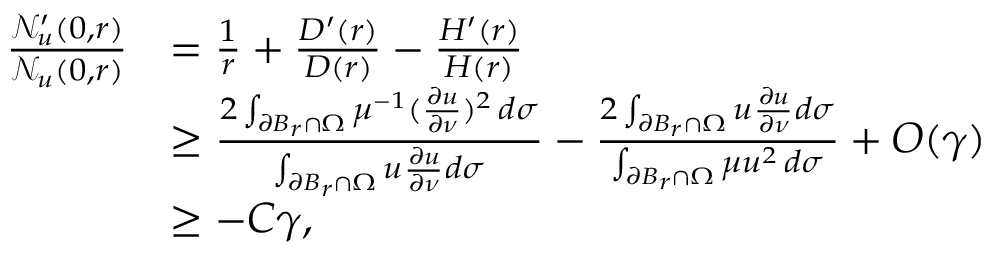<formula> <loc_0><loc_0><loc_500><loc_500>\begin{array} { r } { \begin{array} { r l } { \frac { \mathcal { N } _ { u } ^ { \prime } ( 0 , r ) } { \mathcal { N } _ { u } ( 0 , r ) } } & { = \frac { 1 } { r } + \frac { D ^ { \prime } ( r ) } { D ( r ) } - \frac { H ^ { \prime } ( r ) } { H ( r ) } } \\ & { \geq \frac { 2 \int _ { \partial B _ { r } \cap \Omega } \mu ^ { - 1 } ( \frac { \partial u } { \partial \nu } ) ^ { 2 } \, d \sigma } { \int _ { \partial B _ { r } \cap \Omega } u \frac { \partial u } { \partial \nu } d \sigma } - \frac { 2 \int _ { \partial B _ { r } \cap \Omega } u \frac { \partial u } { \partial \nu } d \sigma } { \int _ { \partial B _ { r } \cap \Omega } \mu u ^ { 2 } \, d \sigma } + O ( \gamma ) } \\ & { \geq - C \gamma , } \end{array} } \end{array}</formula> 